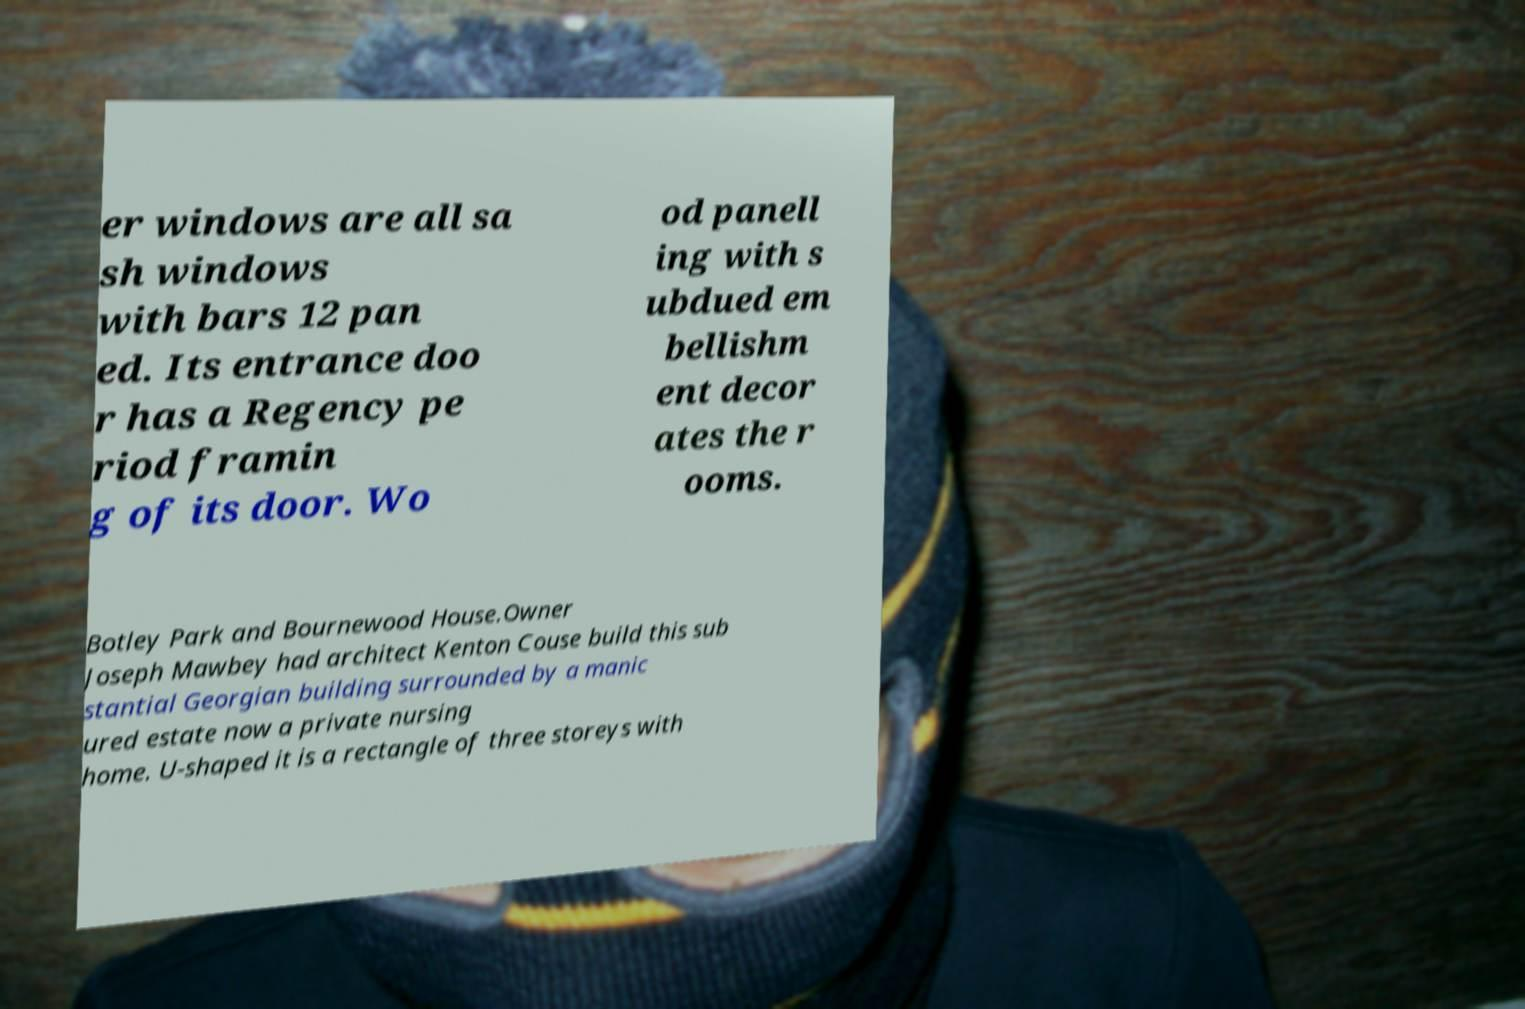Could you assist in decoding the text presented in this image and type it out clearly? er windows are all sa sh windows with bars 12 pan ed. Its entrance doo r has a Regency pe riod framin g of its door. Wo od panell ing with s ubdued em bellishm ent decor ates the r ooms. Botley Park and Bournewood House.Owner Joseph Mawbey had architect Kenton Couse build this sub stantial Georgian building surrounded by a manic ured estate now a private nursing home. U-shaped it is a rectangle of three storeys with 